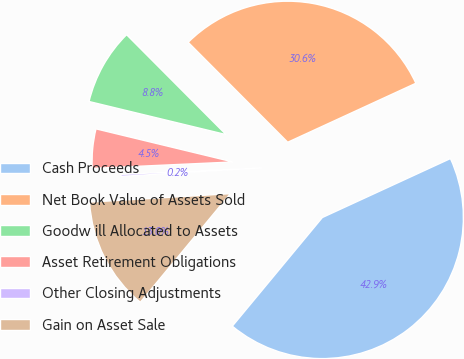Convert chart to OTSL. <chart><loc_0><loc_0><loc_500><loc_500><pie_chart><fcel>Cash Proceeds<fcel>Net Book Value of Assets Sold<fcel>Goodw ill Allocated to Assets<fcel>Asset Retirement Obligations<fcel>Other Closing Adjustments<fcel>Gain on Asset Sale<nl><fcel>42.88%<fcel>30.6%<fcel>8.76%<fcel>4.5%<fcel>0.23%<fcel>13.03%<nl></chart> 